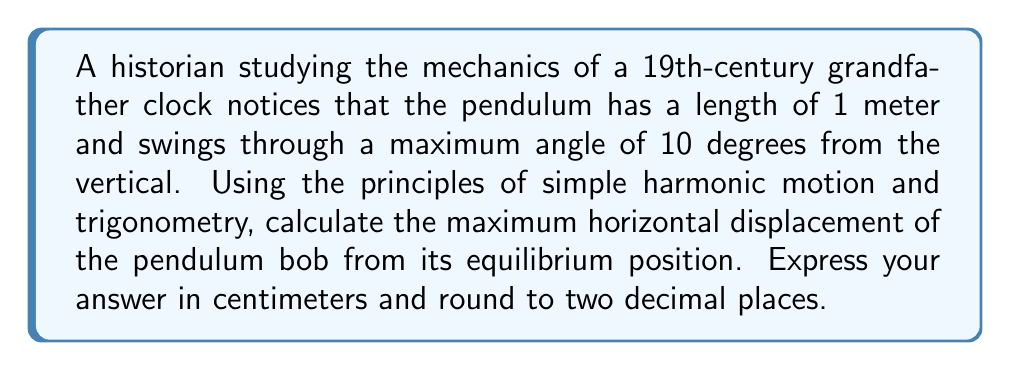Solve this math problem. To solve this problem, we'll use trigonometry to analyze the motion of the pendulum. Let's break it down step-by-step:

1) In a pendulum, the maximum horizontal displacement occurs when the pendulum is at its maximum angle from the vertical.

2) We can visualize this as a right triangle, where:
   - The hypotenuse is the length of the pendulum (1 meter)
   - The angle between the hypotenuse and the vertical is 10 degrees
   - The horizontal displacement is the side opposite to this angle

3) We can use the sine function to find the horizontal displacement:

   $$\sin(\theta) = \frac{\text{opposite}}{\text{hypotenuse}}$$

   Where $\theta$ is the angle and the opposite side is our horizontal displacement.

4) Rearranging this equation:

   $$\text{horizontal displacement} = \text{hypotenuse} \times \sin(\theta)$$

5) Plugging in our values:

   $$\text{horizontal displacement} = 1 \text{ m} \times \sin(10°)$$

6) Using a calculator or trigonometric tables:

   $$\text{horizontal displacement} = 1 \text{ m} \times 0.1736 = 0.1736 \text{ m}$$

7) Converting to centimeters:

   $$0.1736 \text{ m} \times 100 \text{ cm/m} = 17.36 \text{ cm}$$

8) Rounding to two decimal places: 17.36 cm

This result shows how trigonometry can be applied to analyze the motion of historical mechanical devices, combining the historian's interest in antique clocks with principles of physics.
Answer: 17.36 cm 